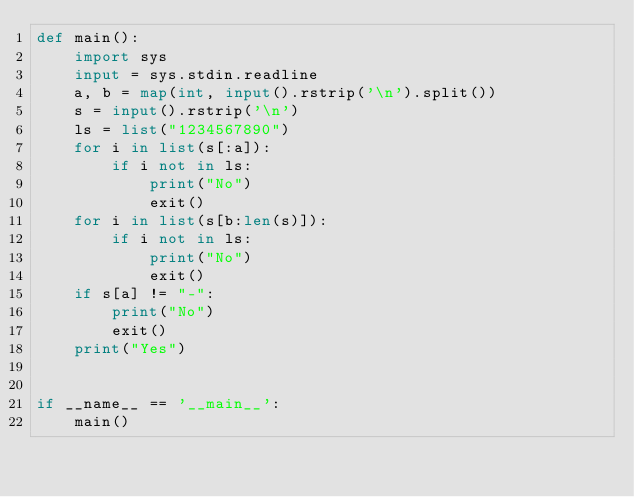Convert code to text. <code><loc_0><loc_0><loc_500><loc_500><_Python_>def main():
    import sys
    input = sys.stdin.readline
    a, b = map(int, input().rstrip('\n').split())
    s = input().rstrip('\n')
    ls = list("1234567890")
    for i in list(s[:a]):
        if i not in ls:
            print("No")
            exit()
    for i in list(s[b:len(s)]):
        if i not in ls:
            print("No")
            exit()
    if s[a] != "-":
        print("No")
        exit()
    print("Yes")


if __name__ == '__main__':
    main()
</code> 